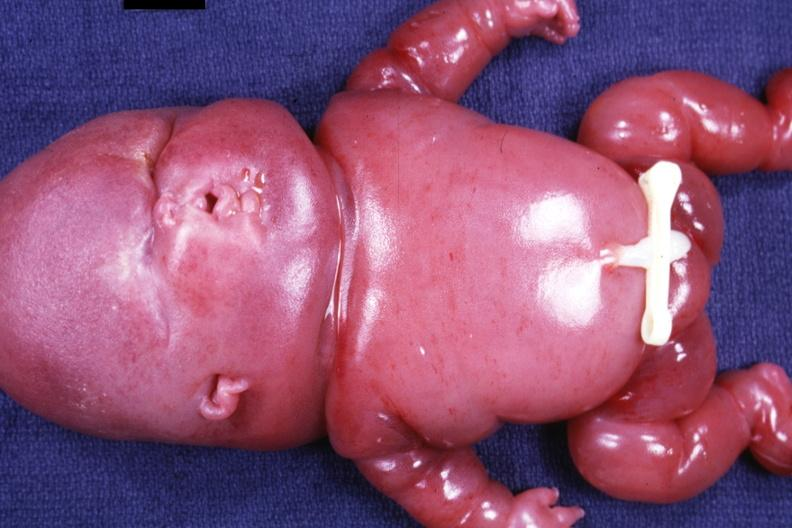s lymphangiomatosis generalized present?
Answer the question using a single word or phrase. Yes 